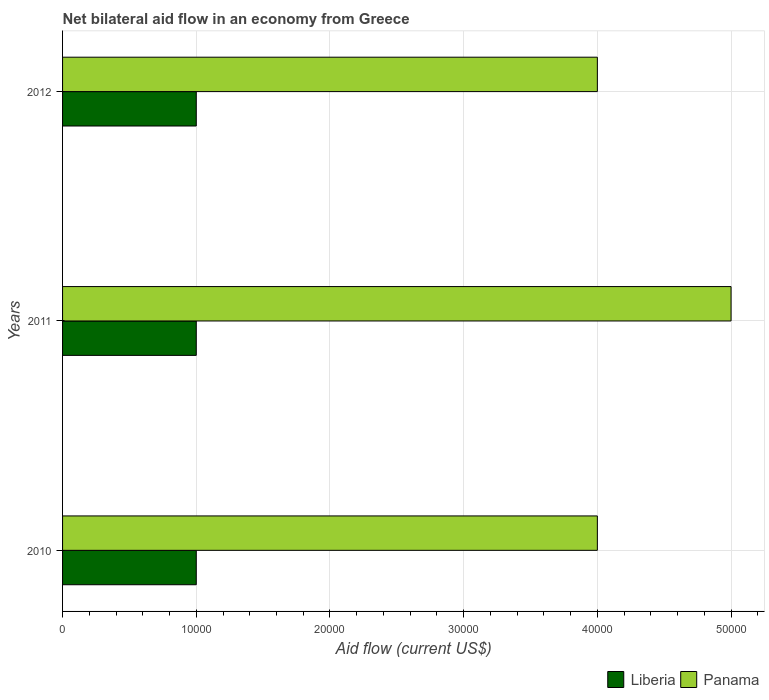How many groups of bars are there?
Ensure brevity in your answer.  3. Are the number of bars per tick equal to the number of legend labels?
Offer a very short reply. Yes. Are the number of bars on each tick of the Y-axis equal?
Offer a very short reply. Yes. In how many cases, is the number of bars for a given year not equal to the number of legend labels?
Ensure brevity in your answer.  0. What is the net bilateral aid flow in Panama in 2010?
Keep it short and to the point. 4.00e+04. What is the total net bilateral aid flow in Panama in the graph?
Make the answer very short. 1.30e+05. What is the difference between the net bilateral aid flow in Liberia in 2010 and that in 2012?
Your answer should be compact. 0. In the year 2011, what is the difference between the net bilateral aid flow in Panama and net bilateral aid flow in Liberia?
Give a very brief answer. 4.00e+04. In how many years, is the net bilateral aid flow in Panama greater than 14000 US$?
Your answer should be compact. 3. What does the 2nd bar from the top in 2012 represents?
Provide a succinct answer. Liberia. What does the 1st bar from the bottom in 2012 represents?
Your answer should be very brief. Liberia. How many bars are there?
Provide a short and direct response. 6. What is the difference between two consecutive major ticks on the X-axis?
Offer a very short reply. 10000. Does the graph contain any zero values?
Make the answer very short. No. Does the graph contain grids?
Keep it short and to the point. Yes. What is the title of the graph?
Provide a short and direct response. Net bilateral aid flow in an economy from Greece. Does "Guinea-Bissau" appear as one of the legend labels in the graph?
Provide a succinct answer. No. What is the label or title of the X-axis?
Provide a succinct answer. Aid flow (current US$). What is the Aid flow (current US$) in Liberia in 2010?
Your answer should be very brief. 10000. What is the Aid flow (current US$) in Liberia in 2011?
Your answer should be compact. 10000. What is the Aid flow (current US$) of Panama in 2011?
Your answer should be compact. 5.00e+04. What is the Aid flow (current US$) of Panama in 2012?
Offer a very short reply. 4.00e+04. Across all years, what is the maximum Aid flow (current US$) in Liberia?
Ensure brevity in your answer.  10000. What is the total Aid flow (current US$) of Panama in the graph?
Provide a succinct answer. 1.30e+05. What is the difference between the Aid flow (current US$) of Liberia in 2010 and that in 2011?
Offer a terse response. 0. What is the difference between the Aid flow (current US$) in Liberia in 2010 and that in 2012?
Keep it short and to the point. 0. What is the difference between the Aid flow (current US$) of Panama in 2011 and that in 2012?
Offer a terse response. 10000. What is the difference between the Aid flow (current US$) of Liberia in 2010 and the Aid flow (current US$) of Panama in 2012?
Your answer should be very brief. -3.00e+04. What is the average Aid flow (current US$) of Liberia per year?
Keep it short and to the point. 10000. What is the average Aid flow (current US$) in Panama per year?
Offer a very short reply. 4.33e+04. In the year 2012, what is the difference between the Aid flow (current US$) of Liberia and Aid flow (current US$) of Panama?
Provide a short and direct response. -3.00e+04. What is the ratio of the Aid flow (current US$) of Panama in 2010 to that in 2011?
Your response must be concise. 0.8. What is the ratio of the Aid flow (current US$) of Liberia in 2011 to that in 2012?
Keep it short and to the point. 1. What is the difference between the highest and the second highest Aid flow (current US$) in Liberia?
Give a very brief answer. 0. What is the difference between the highest and the lowest Aid flow (current US$) in Liberia?
Offer a very short reply. 0. 